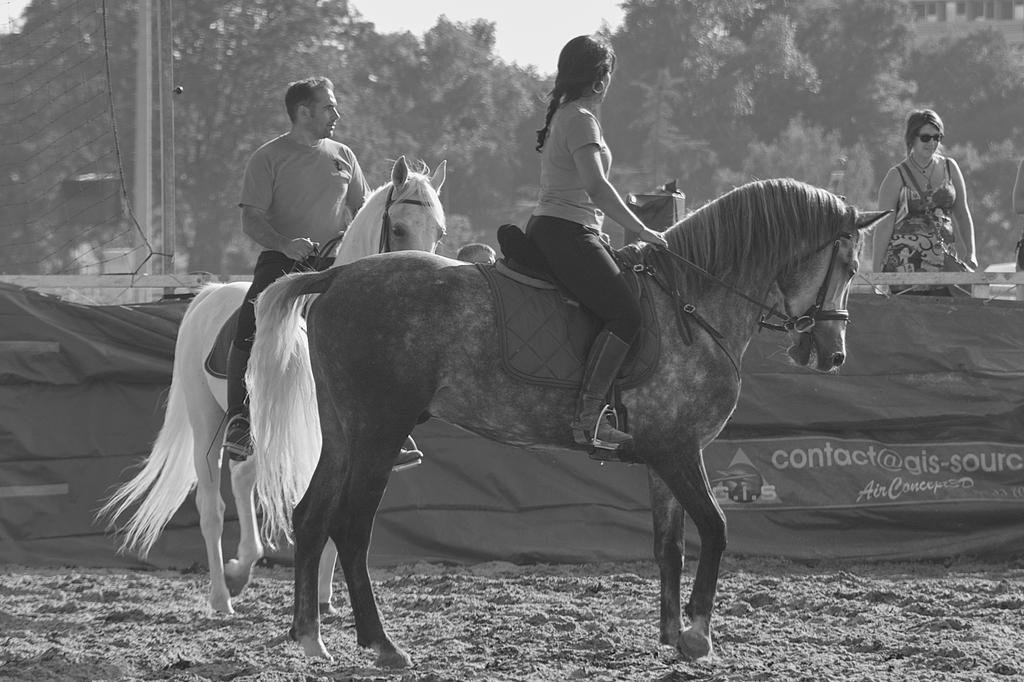How many people are present in the image? There are two people, a man and a woman, present in the image. What are the man and woman doing in the image? The man and woman are sitting on a horse in the image. What can be seen in the background of the image? There are trees and another woman in the background of the image. What type of question can be seen written on the horse's saddle in the image? There is no question visible in the image, and it is not written on the horse's saddle. 